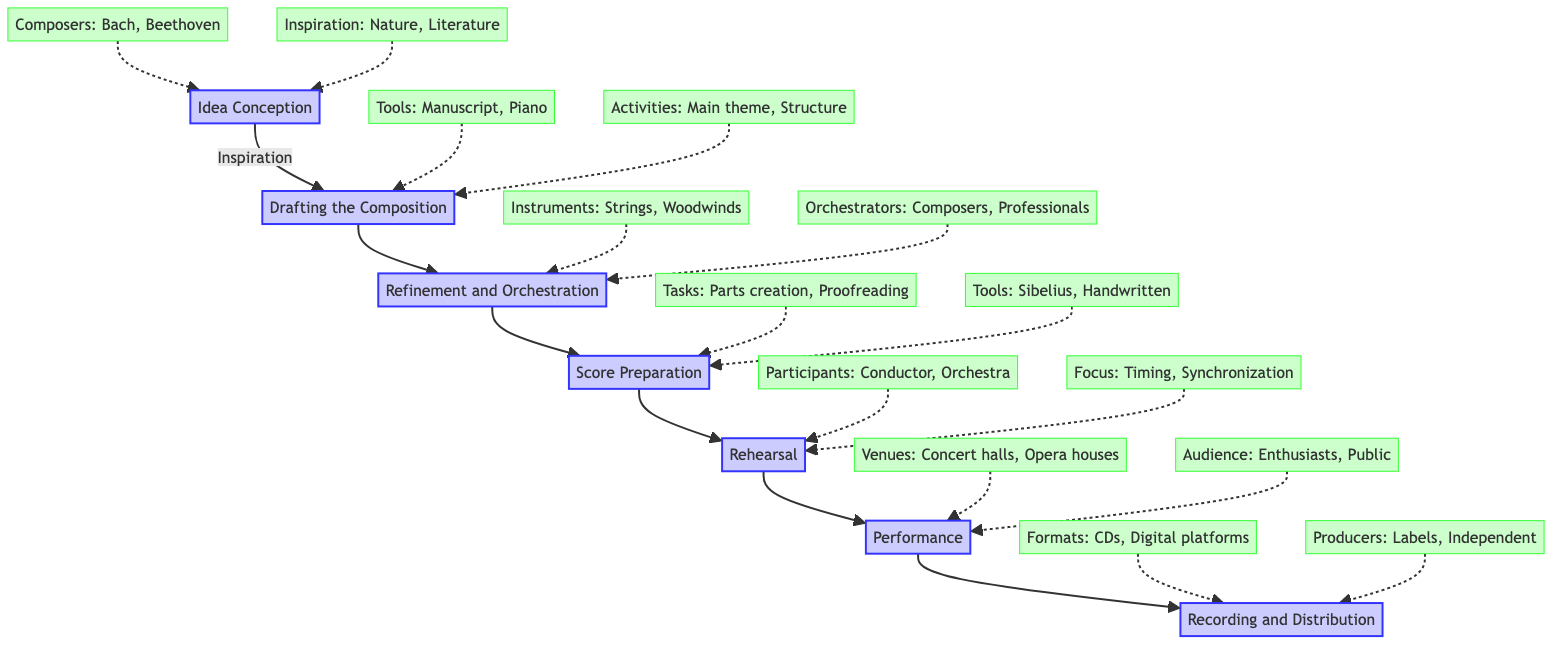What is the first step in the composition journey? The flow chart shows that "Idea Conception" is the first step, leading to "Drafting the Composition".
Answer: Idea Conception How many main stages are there in the flow chart? There are six main stages in the journey, listed from "Idea Conception" to "Recording and Distribution".
Answer: 6 Which composers are mentioned as examples in the "Idea Conception" step? The chart specifies Johann Sebastian Bach and Ludwig van Beethoven as composers in the "Idea Conception" section.
Answer: Bach, Beethoven What tools are used in the "Drafting the Composition" stage? The diagram lists "Manuscript paper" and "Piano or other instrument for drafting" as tools in this stage.
Answer: Manuscript paper, Piano Which instruments are involved in the "Refinement and Orchestration" stage? The chart indicates that "Strings", "Woodwinds", "Brass", and "Percussion" are the instruments involved during this stage.
Answer: Strings, Woodwinds, Brass, Percussion What are the focus areas during the "Rehearsal" stage? The flow chart highlights "Perfecting timing and dynamics" and "Synchronizing parts" as focus areas for rehearsal.
Answer: Timing, Synchronizing What follows after the "Performance" stage in the diagram? According to the flow chart, the stage that follows "Performance" is "Recording and Distribution".
Answer: Recording and Distribution Who are the participants in the "Rehearsal" stage? The chart notes that the participants include "Conductor" and "Orchestra or ensemble".
Answer: Conductor, Orchestra Which formats are mentioned for "Recording and Distribution"? The diagram specifies "CDs" and "Digital platforms like Spotify" as formats for recording and distribution.
Answer: CDs, Digital platforms 